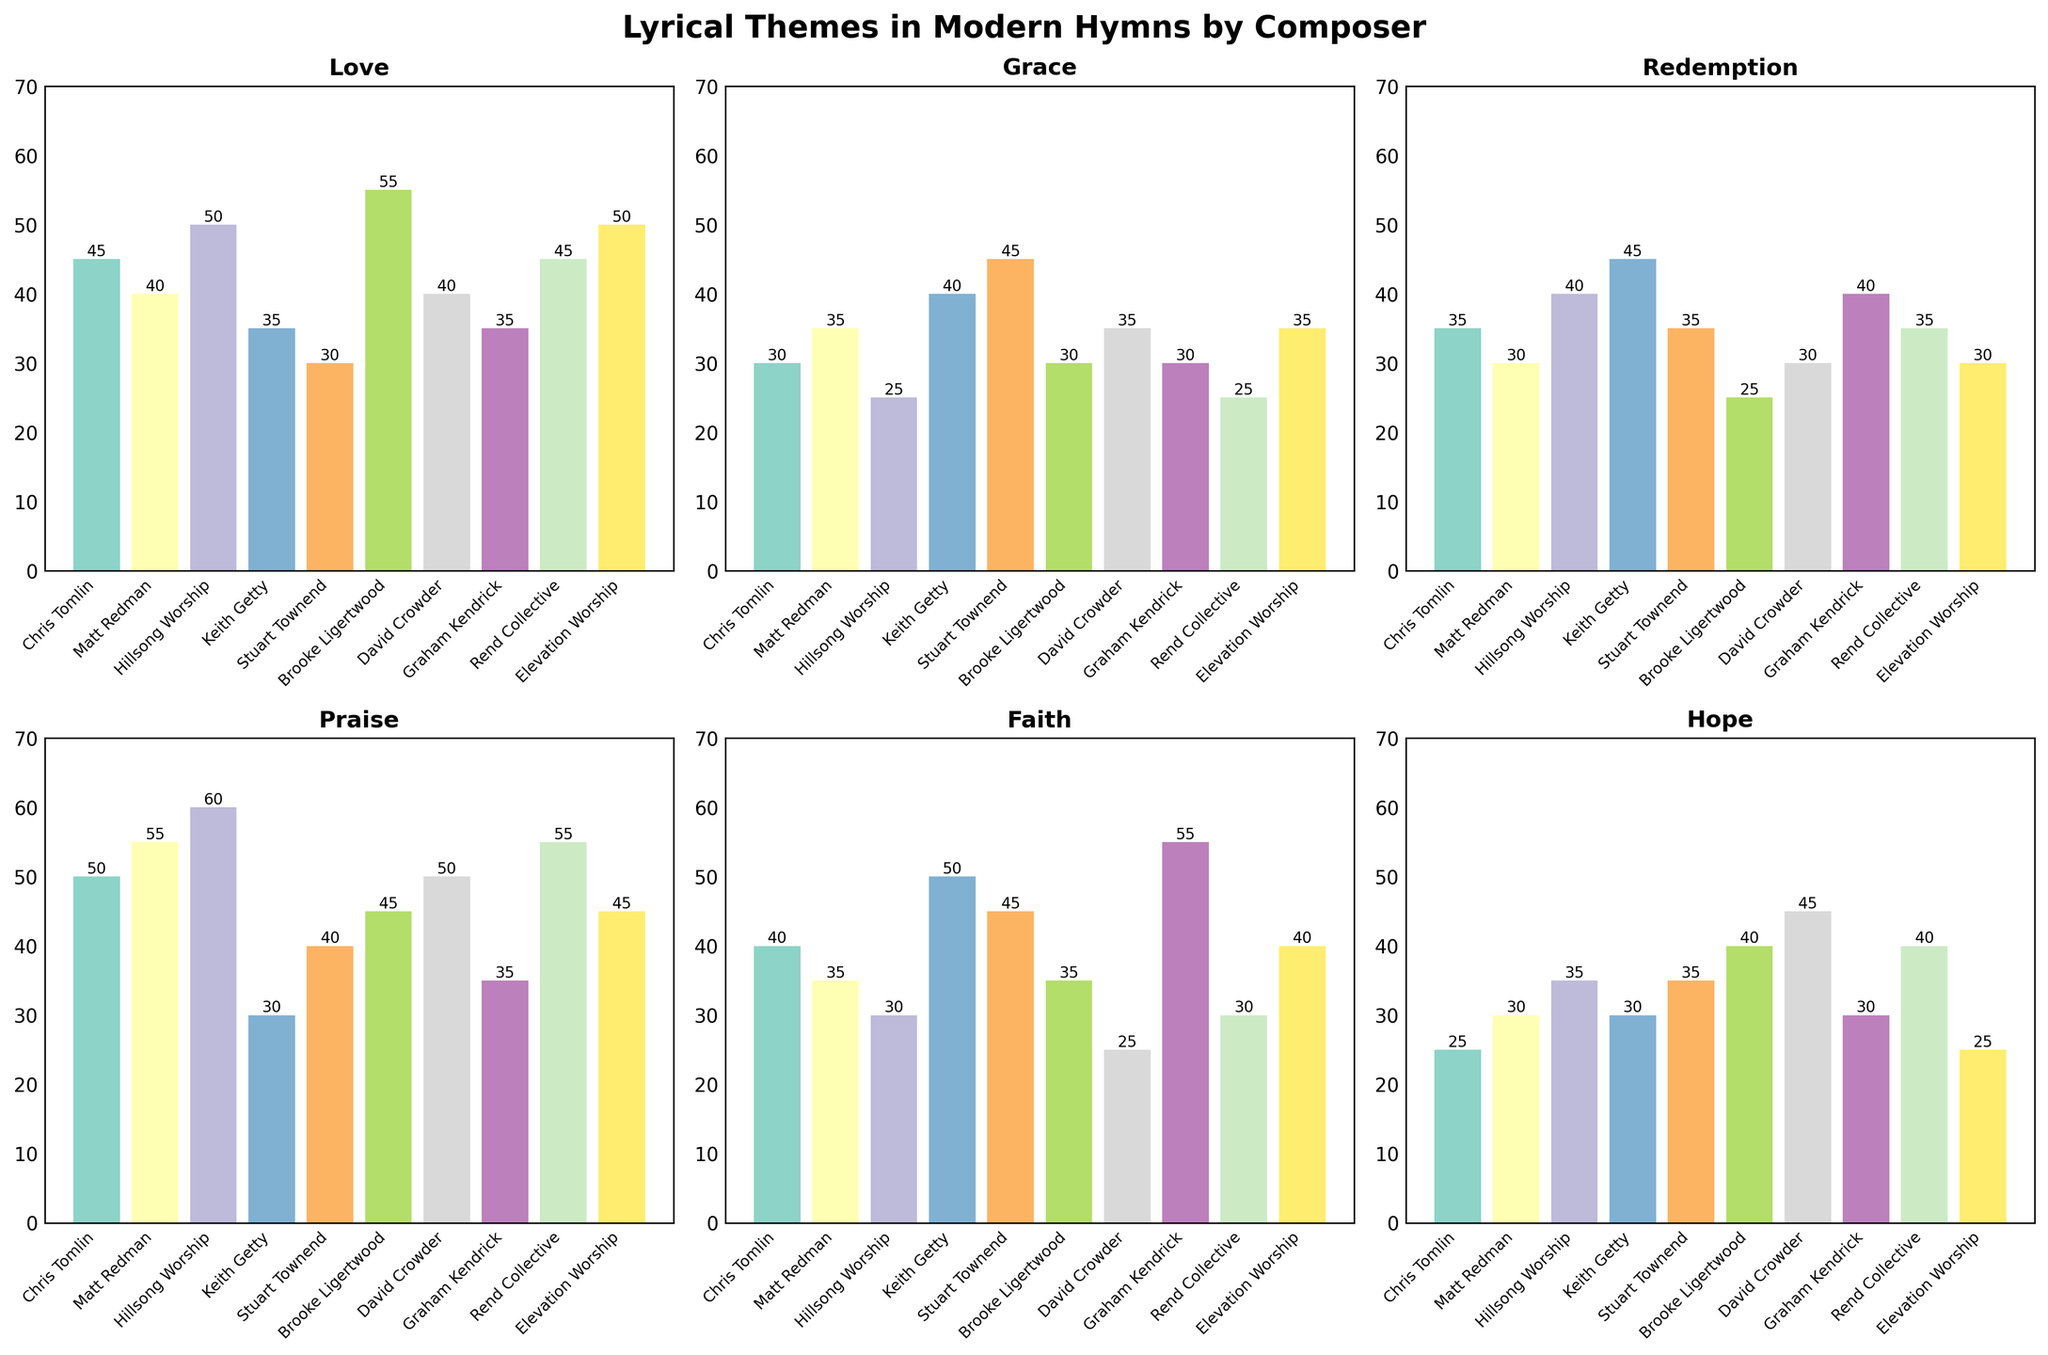What is the title of the figure? The title is displayed at the top center of the figure. It reads as "Lyrical Themes in Modern Hymns by Composer".
Answer: Lyrical Themes in Modern Hymns by Composer Which composer has the highest frequency of the theme "Love"? Look at the "Love" subplot (top left). The tallest bar represents Brooke Ligertwood.
Answer: Brooke Ligertwood Which themes have the same highest frequency value for any composer, and what is the value? Examine all subplots and identify the bars that reach the same maximum height. The themes "Praise" for Hillsong Worship and "Grace" for Stuart Townend both peak at 60.
Answer: Praise, Grace; 60 What is the total frequency count of the theme "Hope" across all composers? Sum all the values in the "Hope" subplot (bottom right): 25 + 30 + 35 + 30 + 35 + 40 + 45 + 30 + 40 + 25 = 335.
Answer: 335 Which composer has the lowest frequency of the theme "Redemption"? In the "Redemption" subplot (middle left), the shortest bar is Brooke Ligertwood's at 25.
Answer: Brooke Ligertwood How many composers have a frequency count of 50 or more for the theme "Faith"? In the "Faith" subplot (bottom middle), count the bars reaching 50 or above. Only Graham Kendrick has 55.
Answer: 1 What is the average frequency count of the "Grace" theme among all composers? Sum the values in the "Grace" subplot: 30 + 35 + 25 + 40 + 45 + 30 + 35 + 30 + 25 + 35 = 330. Divide by 10 composers: 330 / 10 = 33.
Answer: 33 Which theme has the most diverse frequency range across composers? Compare the frequency ranges for each theme in their respective subplots. "Hope" ranges from 25 to 45, while "Grace" ranges from 25 to 45. Both have the difference of 20, but "Hope" visually shows more variation.
Answer: Hope Which composer has a higher frequency count in "Praise" compared to "Redemption"? Check the values in "Praise" (top right) and "Redemption" (middle left). Composers with Praise > Redemption include Chris Tomlin, Matt Redman, Hillsong Worship, Rend Collective.
Answer: Chris Tomlin, Matt Redman, Hillsong Worship, Rend Collective 